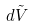Convert formula to latex. <formula><loc_0><loc_0><loc_500><loc_500>d \tilde { V }</formula> 